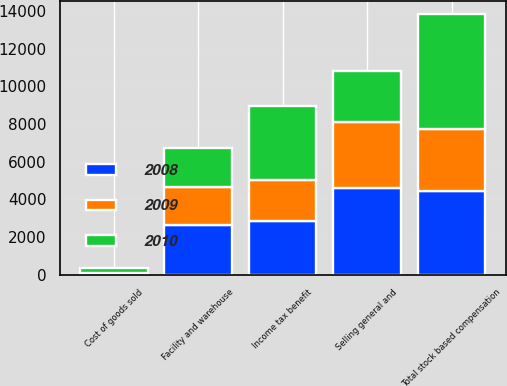Convert chart. <chart><loc_0><loc_0><loc_500><loc_500><stacked_bar_chart><ecel><fcel>Cost of goods sold<fcel>Facility and warehouse<fcel>Selling general and<fcel>Income tax benefit<fcel>Total stock based compensation<nl><fcel>2010<fcel>278<fcel>2069<fcel>2741<fcel>3920<fcel>6054<nl><fcel>2008<fcel>47<fcel>2620<fcel>4616<fcel>2862<fcel>4421<nl><fcel>2009<fcel>13<fcel>2015<fcel>3470<fcel>2166<fcel>3332<nl></chart> 